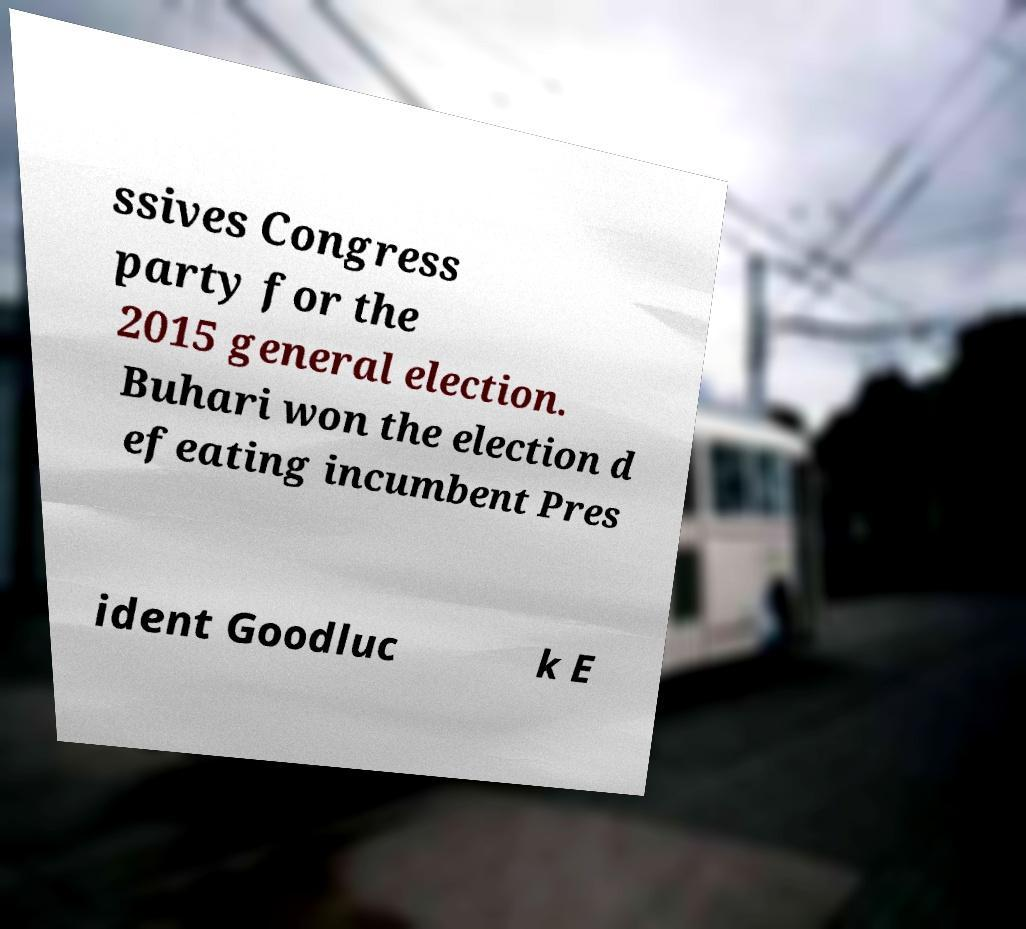I need the written content from this picture converted into text. Can you do that? ssives Congress party for the 2015 general election. Buhari won the election d efeating incumbent Pres ident Goodluc k E 